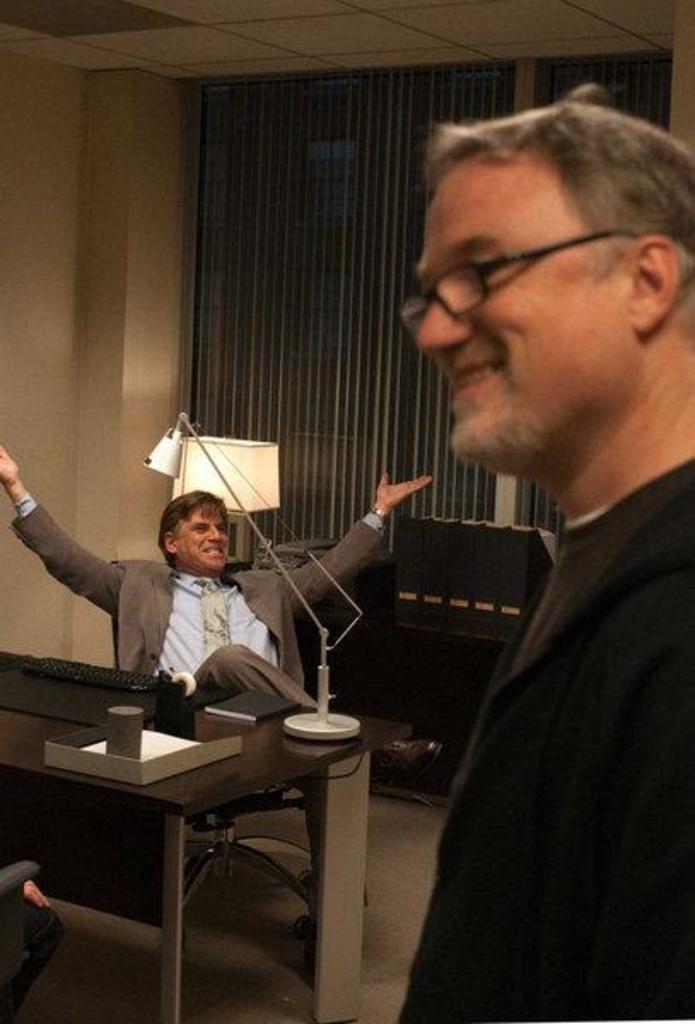In one or two sentences, can you explain what this image depicts? There are two men in which one man is sitting and the other man is standing. There is a table in front of the man who is sitting. On the table there is keyboard,book,lamp,box. At the background there is curtain. At the top there is ceiling. 